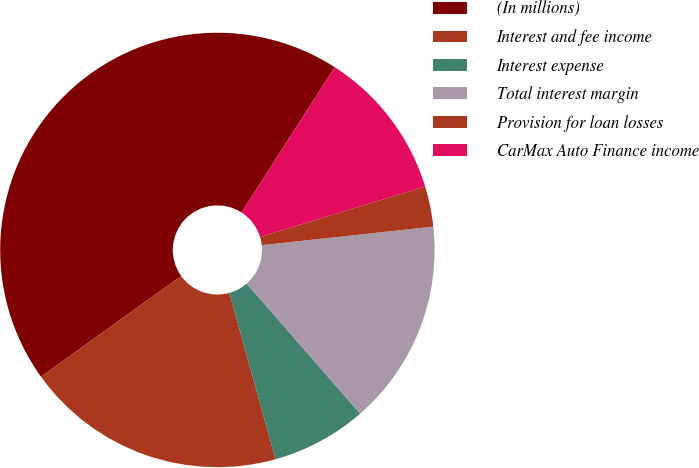Convert chart. <chart><loc_0><loc_0><loc_500><loc_500><pie_chart><fcel>(In millions)<fcel>Interest and fee income<fcel>Interest expense<fcel>Total interest margin<fcel>Provision for loan losses<fcel>CarMax Auto Finance income<nl><fcel>44.0%<fcel>19.4%<fcel>7.1%<fcel>15.3%<fcel>3.0%<fcel>11.2%<nl></chart> 